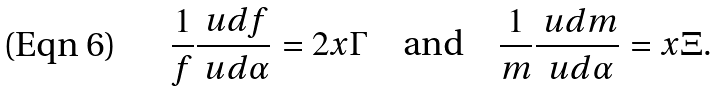Convert formula to latex. <formula><loc_0><loc_0><loc_500><loc_500>\frac { 1 } { f } \frac { \ u d f } { \ u d \alpha } = 2 x \Gamma \quad \text {and} \quad \frac { 1 } { m } \frac { \ u d m } { \ u d \alpha } = x \Xi .</formula> 